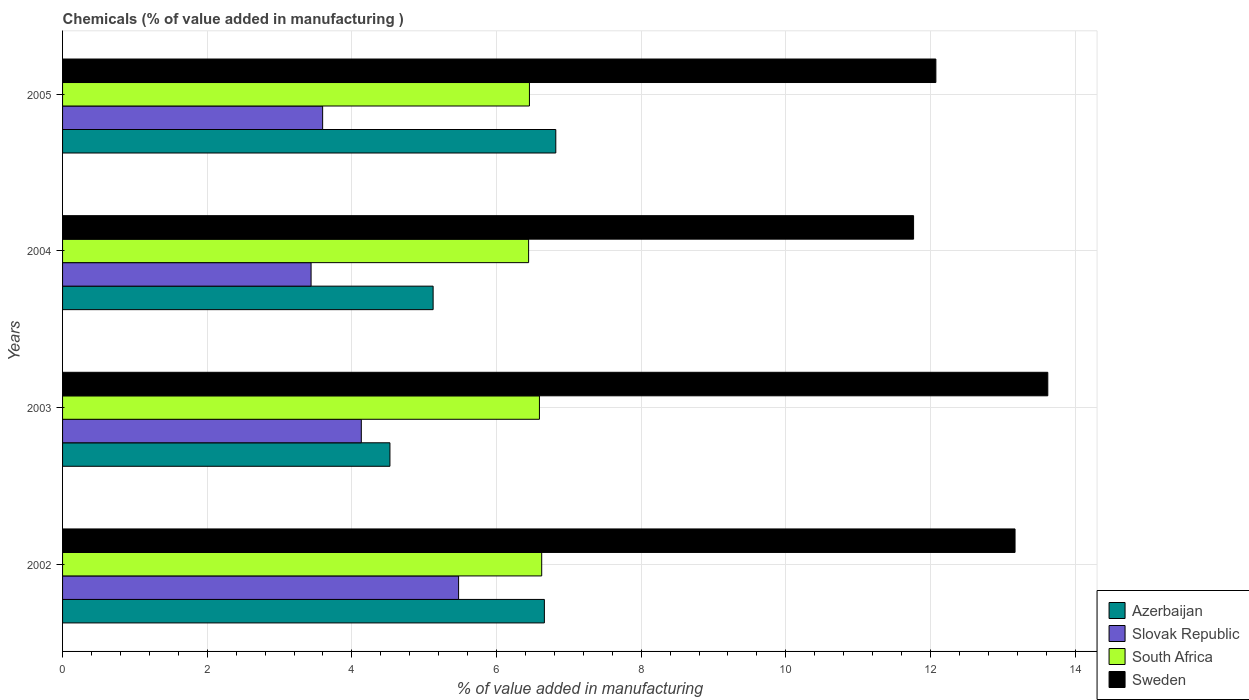How many groups of bars are there?
Give a very brief answer. 4. Are the number of bars per tick equal to the number of legend labels?
Give a very brief answer. Yes. How many bars are there on the 1st tick from the bottom?
Provide a short and direct response. 4. What is the label of the 4th group of bars from the top?
Offer a very short reply. 2002. In how many cases, is the number of bars for a given year not equal to the number of legend labels?
Keep it short and to the point. 0. What is the value added in manufacturing chemicals in Sweden in 2004?
Your response must be concise. 11.77. Across all years, what is the maximum value added in manufacturing chemicals in Slovak Republic?
Ensure brevity in your answer.  5.48. Across all years, what is the minimum value added in manufacturing chemicals in Azerbaijan?
Keep it short and to the point. 4.53. In which year was the value added in manufacturing chemicals in South Africa maximum?
Keep it short and to the point. 2002. In which year was the value added in manufacturing chemicals in Sweden minimum?
Offer a very short reply. 2004. What is the total value added in manufacturing chemicals in Slovak Republic in the graph?
Your answer should be compact. 16.64. What is the difference between the value added in manufacturing chemicals in Sweden in 2002 and that in 2005?
Your response must be concise. 1.09. What is the difference between the value added in manufacturing chemicals in South Africa in 2005 and the value added in manufacturing chemicals in Azerbaijan in 2002?
Your answer should be compact. -0.21. What is the average value added in manufacturing chemicals in South Africa per year?
Offer a terse response. 6.53. In the year 2003, what is the difference between the value added in manufacturing chemicals in Slovak Republic and value added in manufacturing chemicals in Sweden?
Your response must be concise. -9.49. What is the ratio of the value added in manufacturing chemicals in Slovak Republic in 2002 to that in 2003?
Ensure brevity in your answer.  1.33. Is the value added in manufacturing chemicals in South Africa in 2003 less than that in 2004?
Your response must be concise. No. Is the difference between the value added in manufacturing chemicals in Slovak Republic in 2003 and 2005 greater than the difference between the value added in manufacturing chemicals in Sweden in 2003 and 2005?
Your response must be concise. No. What is the difference between the highest and the second highest value added in manufacturing chemicals in Slovak Republic?
Ensure brevity in your answer.  1.34. What is the difference between the highest and the lowest value added in manufacturing chemicals in Sweden?
Offer a terse response. 1.86. Is it the case that in every year, the sum of the value added in manufacturing chemicals in Slovak Republic and value added in manufacturing chemicals in South Africa is greater than the sum of value added in manufacturing chemicals in Azerbaijan and value added in manufacturing chemicals in Sweden?
Provide a succinct answer. No. What does the 1st bar from the top in 2002 represents?
Keep it short and to the point. Sweden. What does the 1st bar from the bottom in 2005 represents?
Provide a succinct answer. Azerbaijan. Is it the case that in every year, the sum of the value added in manufacturing chemicals in Sweden and value added in manufacturing chemicals in South Africa is greater than the value added in manufacturing chemicals in Azerbaijan?
Your answer should be very brief. Yes. How many bars are there?
Offer a very short reply. 16. What is the difference between two consecutive major ticks on the X-axis?
Provide a short and direct response. 2. Are the values on the major ticks of X-axis written in scientific E-notation?
Your response must be concise. No. Does the graph contain any zero values?
Provide a short and direct response. No. Does the graph contain grids?
Provide a succinct answer. Yes. How many legend labels are there?
Provide a succinct answer. 4. How are the legend labels stacked?
Offer a terse response. Vertical. What is the title of the graph?
Your answer should be very brief. Chemicals (% of value added in manufacturing ). What is the label or title of the X-axis?
Your answer should be compact. % of value added in manufacturing. What is the % of value added in manufacturing in Azerbaijan in 2002?
Your answer should be compact. 6.66. What is the % of value added in manufacturing of Slovak Republic in 2002?
Offer a very short reply. 5.48. What is the % of value added in manufacturing in South Africa in 2002?
Give a very brief answer. 6.62. What is the % of value added in manufacturing of Sweden in 2002?
Your answer should be very brief. 13.17. What is the % of value added in manufacturing of Azerbaijan in 2003?
Ensure brevity in your answer.  4.53. What is the % of value added in manufacturing of Slovak Republic in 2003?
Give a very brief answer. 4.13. What is the % of value added in manufacturing of South Africa in 2003?
Offer a very short reply. 6.59. What is the % of value added in manufacturing of Sweden in 2003?
Your answer should be very brief. 13.62. What is the % of value added in manufacturing in Azerbaijan in 2004?
Make the answer very short. 5.12. What is the % of value added in manufacturing of Slovak Republic in 2004?
Give a very brief answer. 3.44. What is the % of value added in manufacturing of South Africa in 2004?
Offer a very short reply. 6.44. What is the % of value added in manufacturing of Sweden in 2004?
Your answer should be compact. 11.77. What is the % of value added in manufacturing of Azerbaijan in 2005?
Offer a terse response. 6.82. What is the % of value added in manufacturing in Slovak Republic in 2005?
Keep it short and to the point. 3.6. What is the % of value added in manufacturing in South Africa in 2005?
Make the answer very short. 6.45. What is the % of value added in manufacturing in Sweden in 2005?
Make the answer very short. 12.07. Across all years, what is the maximum % of value added in manufacturing in Azerbaijan?
Offer a terse response. 6.82. Across all years, what is the maximum % of value added in manufacturing in Slovak Republic?
Your response must be concise. 5.48. Across all years, what is the maximum % of value added in manufacturing of South Africa?
Keep it short and to the point. 6.62. Across all years, what is the maximum % of value added in manufacturing of Sweden?
Give a very brief answer. 13.62. Across all years, what is the minimum % of value added in manufacturing in Azerbaijan?
Ensure brevity in your answer.  4.53. Across all years, what is the minimum % of value added in manufacturing of Slovak Republic?
Provide a succinct answer. 3.44. Across all years, what is the minimum % of value added in manufacturing of South Africa?
Your answer should be compact. 6.44. Across all years, what is the minimum % of value added in manufacturing of Sweden?
Keep it short and to the point. 11.77. What is the total % of value added in manufacturing in Azerbaijan in the graph?
Offer a terse response. 23.13. What is the total % of value added in manufacturing of Slovak Republic in the graph?
Make the answer very short. 16.64. What is the total % of value added in manufacturing in South Africa in the graph?
Your answer should be compact. 26.12. What is the total % of value added in manufacturing of Sweden in the graph?
Your response must be concise. 50.63. What is the difference between the % of value added in manufacturing of Azerbaijan in 2002 and that in 2003?
Offer a very short reply. 2.14. What is the difference between the % of value added in manufacturing in Slovak Republic in 2002 and that in 2003?
Your answer should be compact. 1.34. What is the difference between the % of value added in manufacturing of South Africa in 2002 and that in 2003?
Make the answer very short. 0.03. What is the difference between the % of value added in manufacturing of Sweden in 2002 and that in 2003?
Make the answer very short. -0.45. What is the difference between the % of value added in manufacturing in Azerbaijan in 2002 and that in 2004?
Your answer should be compact. 1.54. What is the difference between the % of value added in manufacturing in Slovak Republic in 2002 and that in 2004?
Offer a terse response. 2.04. What is the difference between the % of value added in manufacturing of South Africa in 2002 and that in 2004?
Give a very brief answer. 0.18. What is the difference between the % of value added in manufacturing of Sweden in 2002 and that in 2004?
Ensure brevity in your answer.  1.4. What is the difference between the % of value added in manufacturing in Azerbaijan in 2002 and that in 2005?
Ensure brevity in your answer.  -0.16. What is the difference between the % of value added in manufacturing in Slovak Republic in 2002 and that in 2005?
Your response must be concise. 1.88. What is the difference between the % of value added in manufacturing of South Africa in 2002 and that in 2005?
Your response must be concise. 0.17. What is the difference between the % of value added in manufacturing of Sweden in 2002 and that in 2005?
Ensure brevity in your answer.  1.09. What is the difference between the % of value added in manufacturing of Azerbaijan in 2003 and that in 2004?
Offer a very short reply. -0.6. What is the difference between the % of value added in manufacturing in Slovak Republic in 2003 and that in 2004?
Offer a terse response. 0.69. What is the difference between the % of value added in manufacturing in South Africa in 2003 and that in 2004?
Provide a short and direct response. 0.15. What is the difference between the % of value added in manufacturing of Sweden in 2003 and that in 2004?
Provide a succinct answer. 1.86. What is the difference between the % of value added in manufacturing in Azerbaijan in 2003 and that in 2005?
Give a very brief answer. -2.29. What is the difference between the % of value added in manufacturing in Slovak Republic in 2003 and that in 2005?
Keep it short and to the point. 0.53. What is the difference between the % of value added in manufacturing in South Africa in 2003 and that in 2005?
Make the answer very short. 0.14. What is the difference between the % of value added in manufacturing of Sweden in 2003 and that in 2005?
Keep it short and to the point. 1.55. What is the difference between the % of value added in manufacturing of Azerbaijan in 2004 and that in 2005?
Your answer should be very brief. -1.7. What is the difference between the % of value added in manufacturing of Slovak Republic in 2004 and that in 2005?
Provide a short and direct response. -0.16. What is the difference between the % of value added in manufacturing in South Africa in 2004 and that in 2005?
Keep it short and to the point. -0.01. What is the difference between the % of value added in manufacturing in Sweden in 2004 and that in 2005?
Keep it short and to the point. -0.31. What is the difference between the % of value added in manufacturing in Azerbaijan in 2002 and the % of value added in manufacturing in Slovak Republic in 2003?
Make the answer very short. 2.53. What is the difference between the % of value added in manufacturing in Azerbaijan in 2002 and the % of value added in manufacturing in South Africa in 2003?
Ensure brevity in your answer.  0.07. What is the difference between the % of value added in manufacturing in Azerbaijan in 2002 and the % of value added in manufacturing in Sweden in 2003?
Your answer should be very brief. -6.96. What is the difference between the % of value added in manufacturing of Slovak Republic in 2002 and the % of value added in manufacturing of South Africa in 2003?
Your answer should be very brief. -1.12. What is the difference between the % of value added in manufacturing in Slovak Republic in 2002 and the % of value added in manufacturing in Sweden in 2003?
Offer a terse response. -8.15. What is the difference between the % of value added in manufacturing of South Africa in 2002 and the % of value added in manufacturing of Sweden in 2003?
Give a very brief answer. -7. What is the difference between the % of value added in manufacturing of Azerbaijan in 2002 and the % of value added in manufacturing of Slovak Republic in 2004?
Your answer should be very brief. 3.23. What is the difference between the % of value added in manufacturing of Azerbaijan in 2002 and the % of value added in manufacturing of South Africa in 2004?
Provide a succinct answer. 0.22. What is the difference between the % of value added in manufacturing in Azerbaijan in 2002 and the % of value added in manufacturing in Sweden in 2004?
Offer a terse response. -5.1. What is the difference between the % of value added in manufacturing in Slovak Republic in 2002 and the % of value added in manufacturing in South Africa in 2004?
Provide a succinct answer. -0.97. What is the difference between the % of value added in manufacturing in Slovak Republic in 2002 and the % of value added in manufacturing in Sweden in 2004?
Give a very brief answer. -6.29. What is the difference between the % of value added in manufacturing of South Africa in 2002 and the % of value added in manufacturing of Sweden in 2004?
Your answer should be very brief. -5.14. What is the difference between the % of value added in manufacturing of Azerbaijan in 2002 and the % of value added in manufacturing of Slovak Republic in 2005?
Provide a short and direct response. 3.07. What is the difference between the % of value added in manufacturing of Azerbaijan in 2002 and the % of value added in manufacturing of South Africa in 2005?
Offer a very short reply. 0.21. What is the difference between the % of value added in manufacturing in Azerbaijan in 2002 and the % of value added in manufacturing in Sweden in 2005?
Offer a terse response. -5.41. What is the difference between the % of value added in manufacturing in Slovak Republic in 2002 and the % of value added in manufacturing in South Africa in 2005?
Make the answer very short. -0.98. What is the difference between the % of value added in manufacturing in Slovak Republic in 2002 and the % of value added in manufacturing in Sweden in 2005?
Provide a succinct answer. -6.6. What is the difference between the % of value added in manufacturing of South Africa in 2002 and the % of value added in manufacturing of Sweden in 2005?
Your answer should be very brief. -5.45. What is the difference between the % of value added in manufacturing in Azerbaijan in 2003 and the % of value added in manufacturing in Slovak Republic in 2004?
Your answer should be very brief. 1.09. What is the difference between the % of value added in manufacturing of Azerbaijan in 2003 and the % of value added in manufacturing of South Africa in 2004?
Keep it short and to the point. -1.92. What is the difference between the % of value added in manufacturing of Azerbaijan in 2003 and the % of value added in manufacturing of Sweden in 2004?
Your answer should be compact. -7.24. What is the difference between the % of value added in manufacturing in Slovak Republic in 2003 and the % of value added in manufacturing in South Africa in 2004?
Keep it short and to the point. -2.31. What is the difference between the % of value added in manufacturing in Slovak Republic in 2003 and the % of value added in manufacturing in Sweden in 2004?
Your answer should be compact. -7.64. What is the difference between the % of value added in manufacturing in South Africa in 2003 and the % of value added in manufacturing in Sweden in 2004?
Provide a short and direct response. -5.17. What is the difference between the % of value added in manufacturing in Azerbaijan in 2003 and the % of value added in manufacturing in Slovak Republic in 2005?
Provide a succinct answer. 0.93. What is the difference between the % of value added in manufacturing of Azerbaijan in 2003 and the % of value added in manufacturing of South Africa in 2005?
Your answer should be compact. -1.93. What is the difference between the % of value added in manufacturing in Azerbaijan in 2003 and the % of value added in manufacturing in Sweden in 2005?
Your response must be concise. -7.55. What is the difference between the % of value added in manufacturing in Slovak Republic in 2003 and the % of value added in manufacturing in South Africa in 2005?
Make the answer very short. -2.32. What is the difference between the % of value added in manufacturing of Slovak Republic in 2003 and the % of value added in manufacturing of Sweden in 2005?
Offer a terse response. -7.94. What is the difference between the % of value added in manufacturing in South Africa in 2003 and the % of value added in manufacturing in Sweden in 2005?
Give a very brief answer. -5.48. What is the difference between the % of value added in manufacturing in Azerbaijan in 2004 and the % of value added in manufacturing in Slovak Republic in 2005?
Offer a very short reply. 1.53. What is the difference between the % of value added in manufacturing of Azerbaijan in 2004 and the % of value added in manufacturing of South Africa in 2005?
Your answer should be very brief. -1.33. What is the difference between the % of value added in manufacturing in Azerbaijan in 2004 and the % of value added in manufacturing in Sweden in 2005?
Offer a very short reply. -6.95. What is the difference between the % of value added in manufacturing of Slovak Republic in 2004 and the % of value added in manufacturing of South Africa in 2005?
Make the answer very short. -3.02. What is the difference between the % of value added in manufacturing of Slovak Republic in 2004 and the % of value added in manufacturing of Sweden in 2005?
Offer a terse response. -8.64. What is the difference between the % of value added in manufacturing of South Africa in 2004 and the % of value added in manufacturing of Sweden in 2005?
Keep it short and to the point. -5.63. What is the average % of value added in manufacturing in Azerbaijan per year?
Your answer should be very brief. 5.78. What is the average % of value added in manufacturing of Slovak Republic per year?
Keep it short and to the point. 4.16. What is the average % of value added in manufacturing in South Africa per year?
Ensure brevity in your answer.  6.53. What is the average % of value added in manufacturing in Sweden per year?
Your response must be concise. 12.66. In the year 2002, what is the difference between the % of value added in manufacturing of Azerbaijan and % of value added in manufacturing of Slovak Republic?
Offer a very short reply. 1.19. In the year 2002, what is the difference between the % of value added in manufacturing of Azerbaijan and % of value added in manufacturing of South Africa?
Ensure brevity in your answer.  0.04. In the year 2002, what is the difference between the % of value added in manufacturing in Azerbaijan and % of value added in manufacturing in Sweden?
Offer a terse response. -6.51. In the year 2002, what is the difference between the % of value added in manufacturing in Slovak Republic and % of value added in manufacturing in South Africa?
Keep it short and to the point. -1.15. In the year 2002, what is the difference between the % of value added in manufacturing of Slovak Republic and % of value added in manufacturing of Sweden?
Offer a terse response. -7.69. In the year 2002, what is the difference between the % of value added in manufacturing in South Africa and % of value added in manufacturing in Sweden?
Your answer should be very brief. -6.54. In the year 2003, what is the difference between the % of value added in manufacturing of Azerbaijan and % of value added in manufacturing of Slovak Republic?
Your response must be concise. 0.4. In the year 2003, what is the difference between the % of value added in manufacturing in Azerbaijan and % of value added in manufacturing in South Africa?
Your answer should be compact. -2.07. In the year 2003, what is the difference between the % of value added in manufacturing in Azerbaijan and % of value added in manufacturing in Sweden?
Your response must be concise. -9.1. In the year 2003, what is the difference between the % of value added in manufacturing in Slovak Republic and % of value added in manufacturing in South Africa?
Your response must be concise. -2.46. In the year 2003, what is the difference between the % of value added in manufacturing in Slovak Republic and % of value added in manufacturing in Sweden?
Make the answer very short. -9.49. In the year 2003, what is the difference between the % of value added in manufacturing in South Africa and % of value added in manufacturing in Sweden?
Provide a succinct answer. -7.03. In the year 2004, what is the difference between the % of value added in manufacturing of Azerbaijan and % of value added in manufacturing of Slovak Republic?
Offer a terse response. 1.69. In the year 2004, what is the difference between the % of value added in manufacturing of Azerbaijan and % of value added in manufacturing of South Africa?
Give a very brief answer. -1.32. In the year 2004, what is the difference between the % of value added in manufacturing of Azerbaijan and % of value added in manufacturing of Sweden?
Offer a very short reply. -6.64. In the year 2004, what is the difference between the % of value added in manufacturing in Slovak Republic and % of value added in manufacturing in South Africa?
Make the answer very short. -3.01. In the year 2004, what is the difference between the % of value added in manufacturing in Slovak Republic and % of value added in manufacturing in Sweden?
Offer a terse response. -8.33. In the year 2004, what is the difference between the % of value added in manufacturing in South Africa and % of value added in manufacturing in Sweden?
Keep it short and to the point. -5.32. In the year 2005, what is the difference between the % of value added in manufacturing in Azerbaijan and % of value added in manufacturing in Slovak Republic?
Offer a very short reply. 3.22. In the year 2005, what is the difference between the % of value added in manufacturing in Azerbaijan and % of value added in manufacturing in South Africa?
Ensure brevity in your answer.  0.36. In the year 2005, what is the difference between the % of value added in manufacturing in Azerbaijan and % of value added in manufacturing in Sweden?
Give a very brief answer. -5.25. In the year 2005, what is the difference between the % of value added in manufacturing in Slovak Republic and % of value added in manufacturing in South Africa?
Your answer should be very brief. -2.86. In the year 2005, what is the difference between the % of value added in manufacturing in Slovak Republic and % of value added in manufacturing in Sweden?
Offer a very short reply. -8.48. In the year 2005, what is the difference between the % of value added in manufacturing of South Africa and % of value added in manufacturing of Sweden?
Offer a very short reply. -5.62. What is the ratio of the % of value added in manufacturing of Azerbaijan in 2002 to that in 2003?
Your answer should be very brief. 1.47. What is the ratio of the % of value added in manufacturing in Slovak Republic in 2002 to that in 2003?
Make the answer very short. 1.33. What is the ratio of the % of value added in manufacturing in Sweden in 2002 to that in 2003?
Your response must be concise. 0.97. What is the ratio of the % of value added in manufacturing of Azerbaijan in 2002 to that in 2004?
Offer a very short reply. 1.3. What is the ratio of the % of value added in manufacturing in Slovak Republic in 2002 to that in 2004?
Make the answer very short. 1.59. What is the ratio of the % of value added in manufacturing of South Africa in 2002 to that in 2004?
Make the answer very short. 1.03. What is the ratio of the % of value added in manufacturing in Sweden in 2002 to that in 2004?
Keep it short and to the point. 1.12. What is the ratio of the % of value added in manufacturing of Azerbaijan in 2002 to that in 2005?
Offer a terse response. 0.98. What is the ratio of the % of value added in manufacturing in Slovak Republic in 2002 to that in 2005?
Give a very brief answer. 1.52. What is the ratio of the % of value added in manufacturing of South Africa in 2002 to that in 2005?
Your answer should be very brief. 1.03. What is the ratio of the % of value added in manufacturing of Sweden in 2002 to that in 2005?
Ensure brevity in your answer.  1.09. What is the ratio of the % of value added in manufacturing in Azerbaijan in 2003 to that in 2004?
Provide a succinct answer. 0.88. What is the ratio of the % of value added in manufacturing of Slovak Republic in 2003 to that in 2004?
Give a very brief answer. 1.2. What is the ratio of the % of value added in manufacturing in South Africa in 2003 to that in 2004?
Offer a very short reply. 1.02. What is the ratio of the % of value added in manufacturing of Sweden in 2003 to that in 2004?
Keep it short and to the point. 1.16. What is the ratio of the % of value added in manufacturing of Azerbaijan in 2003 to that in 2005?
Your answer should be very brief. 0.66. What is the ratio of the % of value added in manufacturing of Slovak Republic in 2003 to that in 2005?
Give a very brief answer. 1.15. What is the ratio of the % of value added in manufacturing of South Africa in 2003 to that in 2005?
Ensure brevity in your answer.  1.02. What is the ratio of the % of value added in manufacturing of Sweden in 2003 to that in 2005?
Keep it short and to the point. 1.13. What is the ratio of the % of value added in manufacturing of Azerbaijan in 2004 to that in 2005?
Your answer should be compact. 0.75. What is the ratio of the % of value added in manufacturing in Slovak Republic in 2004 to that in 2005?
Make the answer very short. 0.96. What is the ratio of the % of value added in manufacturing of South Africa in 2004 to that in 2005?
Keep it short and to the point. 1. What is the ratio of the % of value added in manufacturing of Sweden in 2004 to that in 2005?
Give a very brief answer. 0.97. What is the difference between the highest and the second highest % of value added in manufacturing in Azerbaijan?
Offer a terse response. 0.16. What is the difference between the highest and the second highest % of value added in manufacturing of Slovak Republic?
Offer a terse response. 1.34. What is the difference between the highest and the second highest % of value added in manufacturing in South Africa?
Give a very brief answer. 0.03. What is the difference between the highest and the second highest % of value added in manufacturing in Sweden?
Keep it short and to the point. 0.45. What is the difference between the highest and the lowest % of value added in manufacturing of Azerbaijan?
Provide a short and direct response. 2.29. What is the difference between the highest and the lowest % of value added in manufacturing in Slovak Republic?
Your response must be concise. 2.04. What is the difference between the highest and the lowest % of value added in manufacturing of South Africa?
Offer a very short reply. 0.18. What is the difference between the highest and the lowest % of value added in manufacturing in Sweden?
Provide a short and direct response. 1.86. 